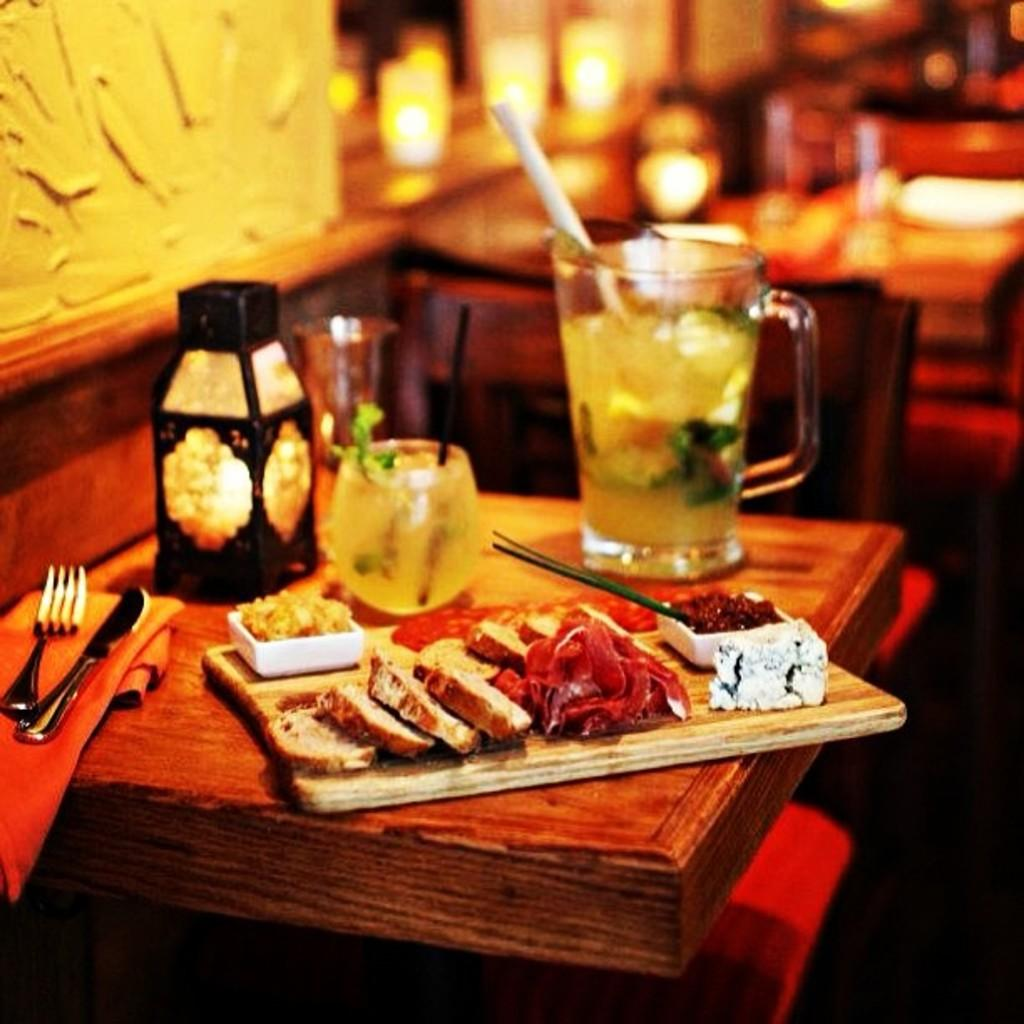What is on the table in the image? There is a glass, a lamp, a wood plate, food, a fork, a knife, and a cloth on the table in the image. What type of food is on the table? The facts do not specify the type of food on the table. What is the purpose of the fork and knife on the table? The fork and knife are likely used for eating the food on the table. What can be seen in the background of the image? There is a wall visible in the background. Where is the toothbrush located in the image? There is no toothbrush present in the image. What type of coat is hanging on the wall in the image? There is no coat visible in the image; only a wall is mentioned in the background. 